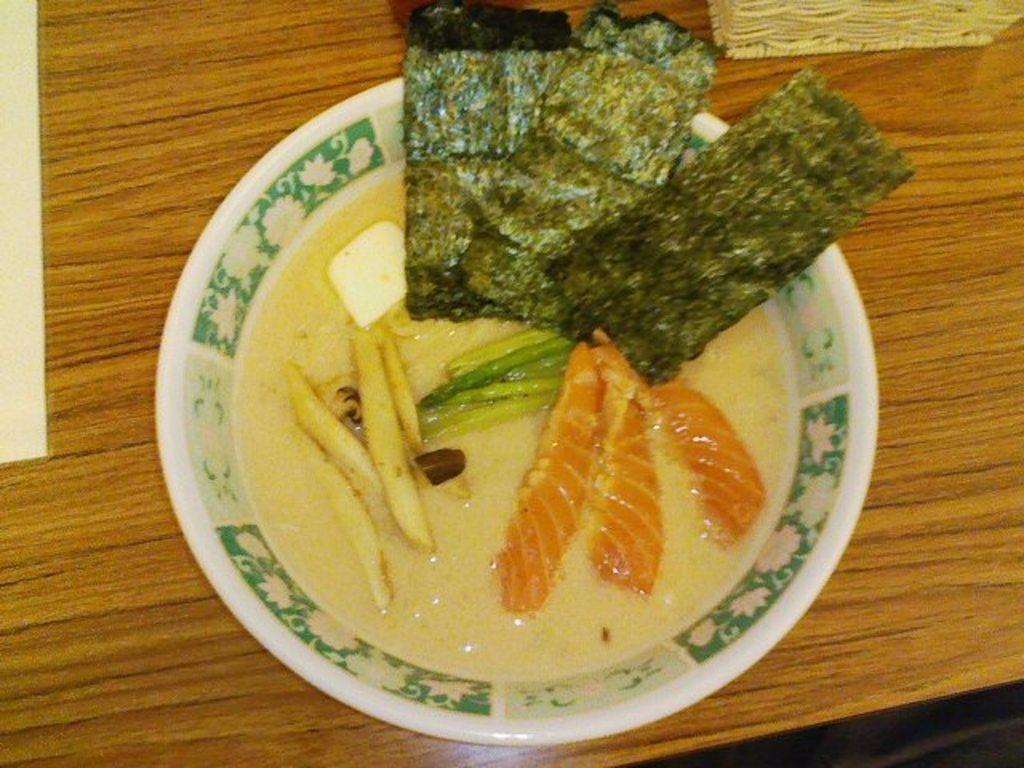What type of furniture is present in the image? There is a table in the image. What is on top of the table? There is a bowl on the table. What is inside the bowl? The bowl contains soup. What type of ingredients can be seen in the soup? There are vegetable slices in the bowl. How does the frame of the table talk to the soup in the image? The frame of the table does not talk to the soup in the image, as they are both inanimate objects. 